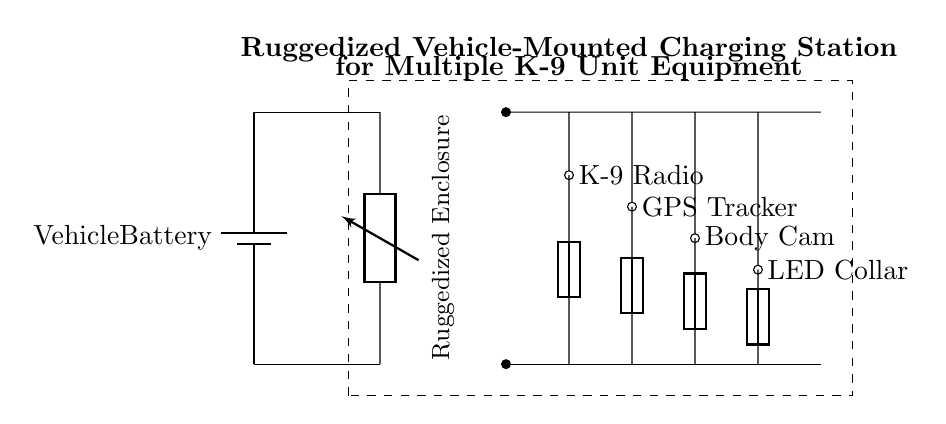What is the power source for this charging station? The circuit diagram indicates that the power source is the vehicle battery, which is located at the left of the diagram.
Answer: Vehicle Battery How many charging ports are available in this circuit? In the diagram, there are four charging ports labeled for different K-9 unit equipment: Radio, GPS Tracker, Body Cam, and LED Collar.
Answer: Four What component is used to protect each charging port? The diagram shows that each charging port is connected to a fuse, which acts as a protective device to prevent overcurrent.
Answer: Fuse What is the purpose of the DC-DC converter in this circuit? The DC-DC converter adapts the voltage from the vehicle battery to a suitable level for the K-9 equipment being charged, ensuring proper functionality.
Answer: Voltage adaptation Which charging port is connected to the K-9 Radio? The K-9 Radio charging port is located on the far left side of the power distribution line at the top of the diagram.
Answer: K-9 Radio What is the significance of the ruggedized enclosure? The ruggedized enclosure is designed to protect the components of the charging station from external mechanical damage and environmental conditions, ensuring durability and reliability.
Answer: Protection What are the short lines labeled with asterisks and arrows representing? These short lines indicate connections from the power distribution to the respective charging ports for each K-9 equipment, showing where the electrical flow goes.
Answer: Charging connections 